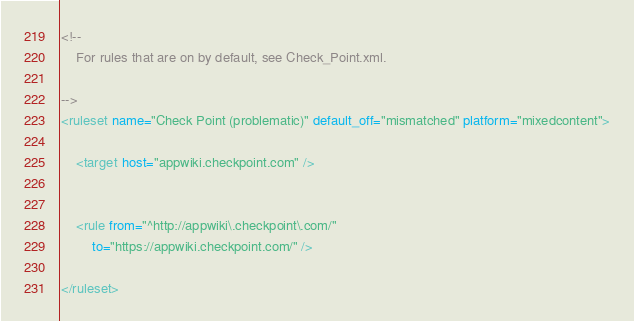<code> <loc_0><loc_0><loc_500><loc_500><_XML_><!--
	For rules that are on by default, see Check_Point.xml.

-->
<ruleset name="Check Point (problematic)" default_off="mismatched" platform="mixedcontent">

	<target host="appwiki.checkpoint.com" />


	<rule from="^http://appwiki\.checkpoint\.com/"
		to="https://appwiki.checkpoint.com/" />

</ruleset></code> 